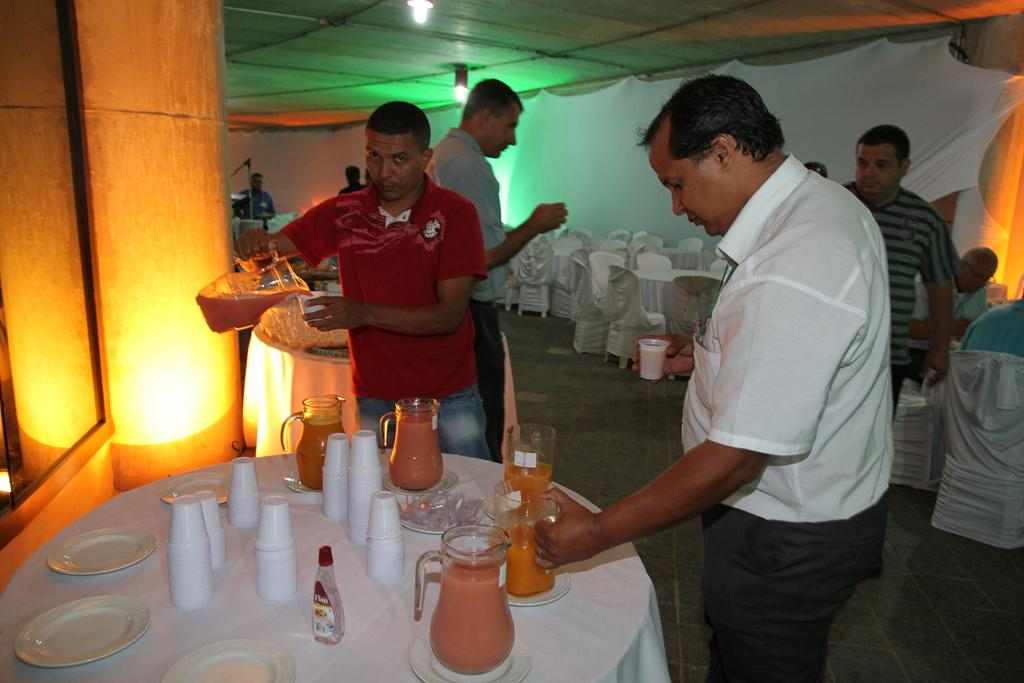What type of structure is visible in the image? There is a wall in the image. What type of furniture is present in the image? There are chairs and tables in the image. What are the people in the image doing? The people are standing in the image. Where are the people standing? The people are standing on the floor. What items can be seen on the table in the image? There are glasses, mugs, and plates on the table. Can you see any caves in the image? There are no caves present in the image. How many hands are visible in the image? There is no mention of hands in the provided facts, so it cannot be determined how many hands are visible in the image. 